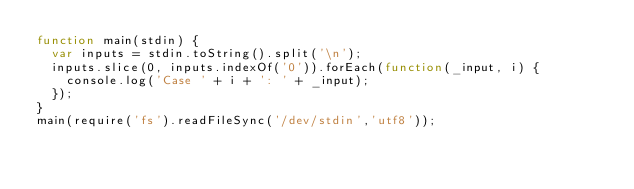<code> <loc_0><loc_0><loc_500><loc_500><_JavaScript_>function main(stdin) {
  var inputs = stdin.toString().split('\n');
  inputs.slice(0, inputs.indexOf('0')).forEach(function(_input, i) {
    console.log('Case ' + i + ': ' + _input);
  });
}
main(require('fs').readFileSync('/dev/stdin','utf8'));</code> 